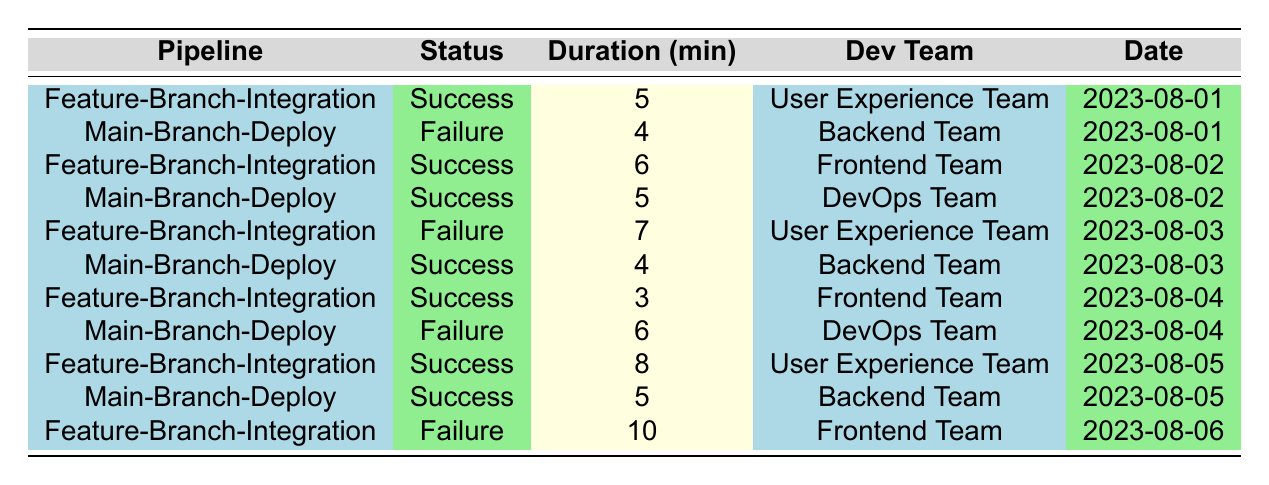What is the status of the build with commit ID def5678? The table lists the status of each build along with its corresponding commit ID. The commit ID def5678 is associated with the "Main-Branch-Deploy" pipeline and has a status of "Failure."
Answer: Failure How many builds were successful in the "Feature-Branch-Integration" pipeline? The table contains a total of 5 entries for the "Feature-Branch-Integration" pipeline. Out of these, 3 entries have a status of "Success."
Answer: 3 What was the duration of the longest build in the table? The table shows the duration for each build. The maximum duration is found by comparing all the values in the "Duration (min)" column. The longest duration is 10 minutes, which corresponds to the build with commit ID def67890.
Answer: 10 minutes Did the "DevOps Team" have any failures in their builds? Looking at the entries in the table for builds associated with the "DevOps Team," there are two entries: one is "Success" and the other is "Failure." Hence, the answer is yes, they had a failure.
Answer: Yes What is the average duration of successful builds in the "Main-Branch-Deploy" pipeline? The "Main-Branch-Deploy" pipeline has 4 successful builds. Their durations are 5, 4, and 5 minutes. To find the average, sum these durations (5 + 4 + 5 = 14), then divide by the number of successful builds (14/3 ≈ 4.67).
Answer: Approximately 4.67 minutes Which development team had the most failures across all builds? By reviewing the table, we can count the failures associated with each development team. The "Frontend Team" has 2 failures, the "User Experience Team" has 1, the "Backend Team" has 0, and the "DevOps Team" has 1. Therefore, the "Frontend Team" had the most failures.
Answer: Frontend Team What is the total count of builds that occurred on August 3rd? Referring to the timestamps in the table, there are two builds on August 3rd: one is a "Failure" in the "Feature-Branch-Integration" pipeline and the other is a "Success" in the "Main-Branch-Deploy" pipeline. Thus, there are a total of 2 builds on that date.
Answer: 2 What is the build status of the earliest build entry in the table? The earliest timestamp is from the build with commit ID abc1234, which occurs on August 1st. The status of this build is "Success." Therefore, the answer is based on the first entry in the table.
Answer: Success How many builds were performed by the "Backend Team"? The table shows three builds done by the "Backend Team" on different days, evaluating both successful and unsuccessful builds. Thus, the total count is 3.
Answer: 3 